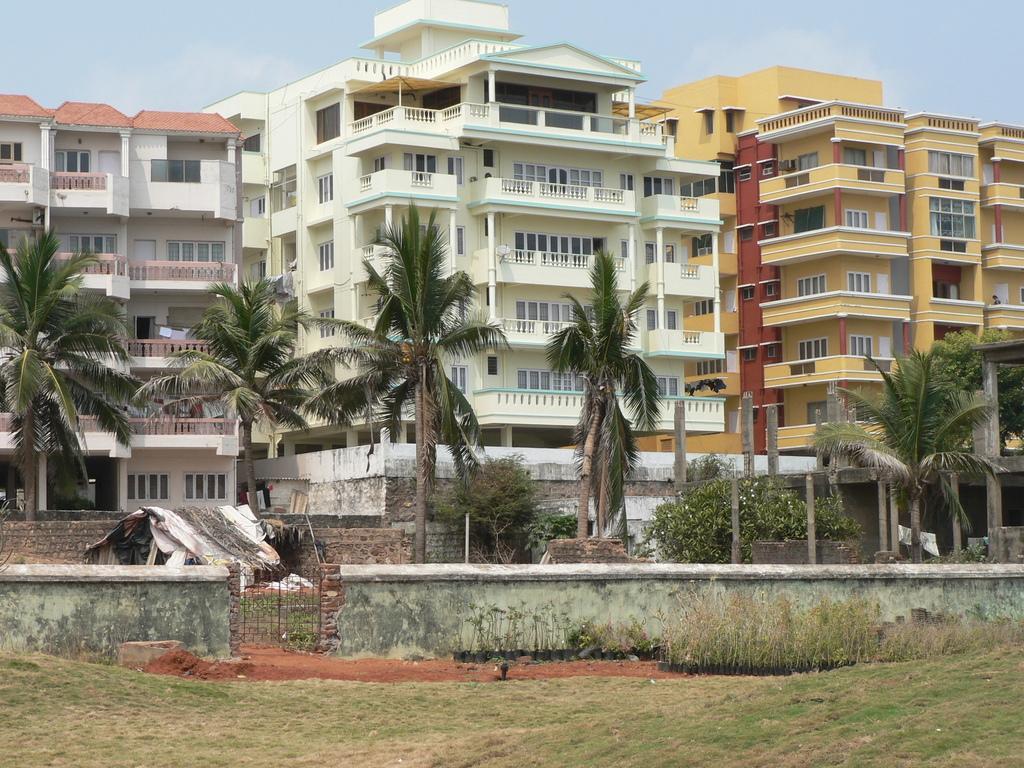Please provide a concise description of this image. In this image I can see the hut, few trees in green color. In the background I can see few buildings and the sky is in white and blue color. 